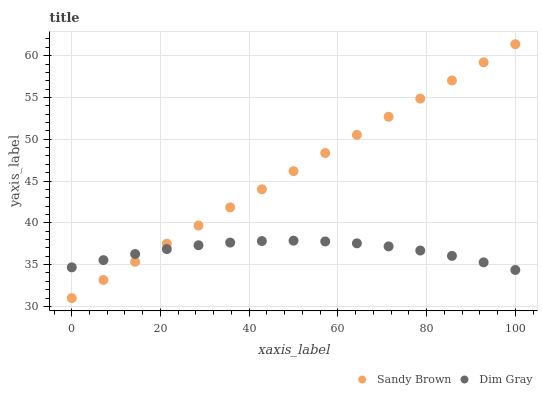Does Dim Gray have the minimum area under the curve?
Answer yes or no. Yes. Does Sandy Brown have the maximum area under the curve?
Answer yes or no. Yes. Does Sandy Brown have the minimum area under the curve?
Answer yes or no. No. Is Sandy Brown the smoothest?
Answer yes or no. Yes. Is Dim Gray the roughest?
Answer yes or no. Yes. Is Sandy Brown the roughest?
Answer yes or no. No. Does Sandy Brown have the lowest value?
Answer yes or no. Yes. Does Sandy Brown have the highest value?
Answer yes or no. Yes. Does Dim Gray intersect Sandy Brown?
Answer yes or no. Yes. Is Dim Gray less than Sandy Brown?
Answer yes or no. No. Is Dim Gray greater than Sandy Brown?
Answer yes or no. No. 